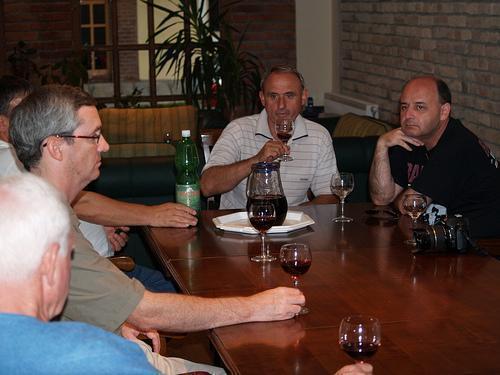What can happen if too much of this liquid is ingested?
Make your selection from the four choices given to correctly answer the question.
Options: Floatation, sickness, strangulation, hypnosis. Sickness. 